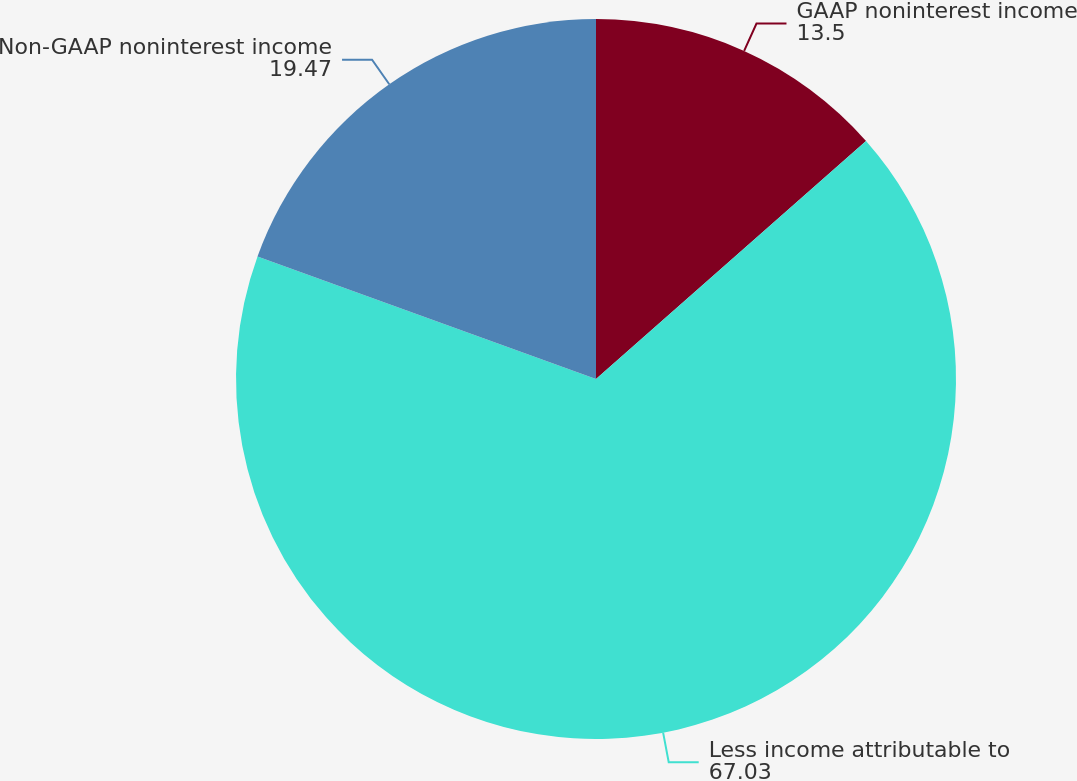Convert chart to OTSL. <chart><loc_0><loc_0><loc_500><loc_500><pie_chart><fcel>GAAP noninterest income<fcel>Less income attributable to<fcel>Non-GAAP noninterest income<nl><fcel>13.5%<fcel>67.03%<fcel>19.47%<nl></chart> 